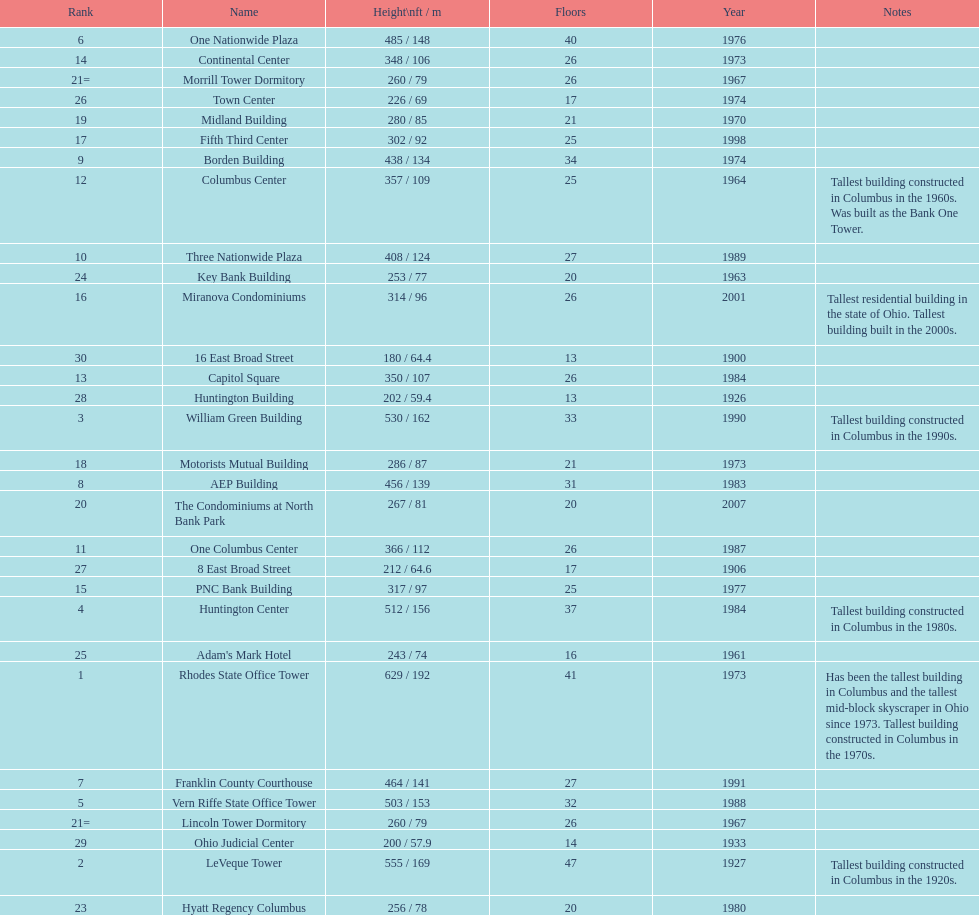Write the full table. {'header': ['Rank', 'Name', 'Height\\nft / m', 'Floors', 'Year', 'Notes'], 'rows': [['6', 'One Nationwide Plaza', '485 / 148', '40', '1976', ''], ['14', 'Continental Center', '348 / 106', '26', '1973', ''], ['21=', 'Morrill Tower Dormitory', '260 / 79', '26', '1967', ''], ['26', 'Town Center', '226 / 69', '17', '1974', ''], ['19', 'Midland Building', '280 / 85', '21', '1970', ''], ['17', 'Fifth Third Center', '302 / 92', '25', '1998', ''], ['9', 'Borden Building', '438 / 134', '34', '1974', ''], ['12', 'Columbus Center', '357 / 109', '25', '1964', 'Tallest building constructed in Columbus in the 1960s. Was built as the Bank One Tower.'], ['10', 'Three Nationwide Plaza', '408 / 124', '27', '1989', ''], ['24', 'Key Bank Building', '253 / 77', '20', '1963', ''], ['16', 'Miranova Condominiums', '314 / 96', '26', '2001', 'Tallest residential building in the state of Ohio. Tallest building built in the 2000s.'], ['30', '16 East Broad Street', '180 / 64.4', '13', '1900', ''], ['13', 'Capitol Square', '350 / 107', '26', '1984', ''], ['28', 'Huntington Building', '202 / 59.4', '13', '1926', ''], ['3', 'William Green Building', '530 / 162', '33', '1990', 'Tallest building constructed in Columbus in the 1990s.'], ['18', 'Motorists Mutual Building', '286 / 87', '21', '1973', ''], ['8', 'AEP Building', '456 / 139', '31', '1983', ''], ['20', 'The Condominiums at North Bank Park', '267 / 81', '20', '2007', ''], ['11', 'One Columbus Center', '366 / 112', '26', '1987', ''], ['27', '8 East Broad Street', '212 / 64.6', '17', '1906', ''], ['15', 'PNC Bank Building', '317 / 97', '25', '1977', ''], ['4', 'Huntington Center', '512 / 156', '37', '1984', 'Tallest building constructed in Columbus in the 1980s.'], ['25', "Adam's Mark Hotel", '243 / 74', '16', '1961', ''], ['1', 'Rhodes State Office Tower', '629 / 192', '41', '1973', 'Has been the tallest building in Columbus and the tallest mid-block skyscraper in Ohio since 1973. Tallest building constructed in Columbus in the 1970s.'], ['7', 'Franklin County Courthouse', '464 / 141', '27', '1991', ''], ['5', 'Vern Riffe State Office Tower', '503 / 153', '32', '1988', ''], ['21=', 'Lincoln Tower Dormitory', '260 / 79', '26', '1967', ''], ['29', 'Ohio Judicial Center', '200 / 57.9', '14', '1933', ''], ['2', 'LeVeque Tower', '555 / 169', '47', '1927', 'Tallest building constructed in Columbus in the 1920s.'], ['23', 'Hyatt Regency Columbus', '256 / 78', '20', '1980', '']]} Which is the tallest building? Rhodes State Office Tower. 